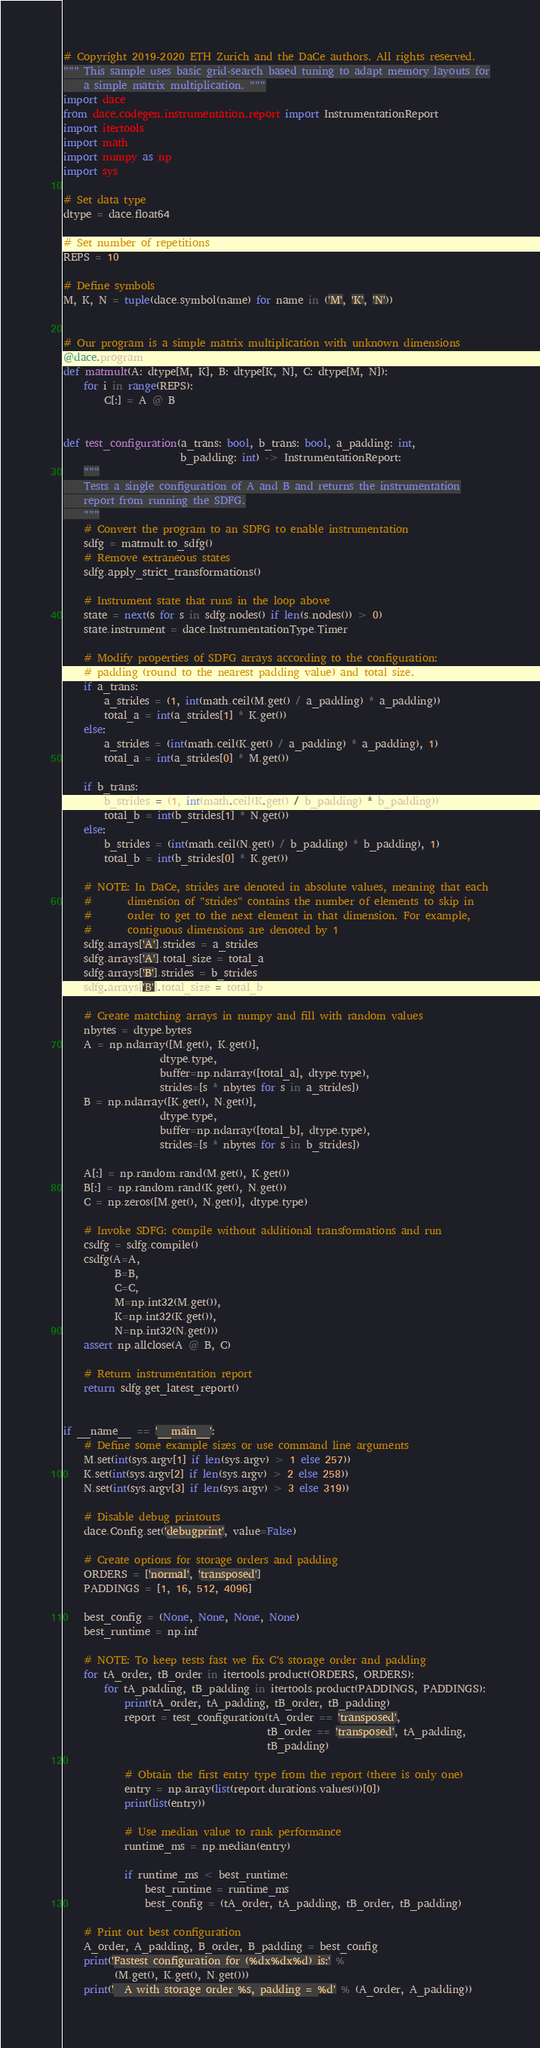Convert code to text. <code><loc_0><loc_0><loc_500><loc_500><_Python_># Copyright 2019-2020 ETH Zurich and the DaCe authors. All rights reserved.
""" This sample uses basic grid-search based tuning to adapt memory layouts for
    a simple matrix multiplication. """
import dace
from dace.codegen.instrumentation.report import InstrumentationReport
import itertools
import math
import numpy as np
import sys

# Set data type
dtype = dace.float64

# Set number of repetitions
REPS = 10

# Define symbols
M, K, N = tuple(dace.symbol(name) for name in ('M', 'K', 'N'))


# Our program is a simple matrix multiplication with unknown dimensions
@dace.program
def matmult(A: dtype[M, K], B: dtype[K, N], C: dtype[M, N]):
    for i in range(REPS):
        C[:] = A @ B


def test_configuration(a_trans: bool, b_trans: bool, a_padding: int,
                       b_padding: int) -> InstrumentationReport:
    """
    Tests a single configuration of A and B and returns the instrumentation
    report from running the SDFG.
    """
    # Convert the program to an SDFG to enable instrumentation
    sdfg = matmult.to_sdfg()
    # Remove extraneous states
    sdfg.apply_strict_transformations()

    # Instrument state that runs in the loop above
    state = next(s for s in sdfg.nodes() if len(s.nodes()) > 0)
    state.instrument = dace.InstrumentationType.Timer

    # Modify properties of SDFG arrays according to the configuration:
    # padding (round to the nearest padding value) and total size.
    if a_trans:
        a_strides = (1, int(math.ceil(M.get() / a_padding) * a_padding))
        total_a = int(a_strides[1] * K.get())
    else:
        a_strides = (int(math.ceil(K.get() / a_padding) * a_padding), 1)
        total_a = int(a_strides[0] * M.get())

    if b_trans:
        b_strides = (1, int(math.ceil(K.get() / b_padding) * b_padding))
        total_b = int(b_strides[1] * N.get())
    else:
        b_strides = (int(math.ceil(N.get() / b_padding) * b_padding), 1)
        total_b = int(b_strides[0] * K.get())

    # NOTE: In DaCe, strides are denoted in absolute values, meaning that each
    #       dimension of "strides" contains the number of elements to skip in
    #       order to get to the next element in that dimension. For example,
    #       contiguous dimensions are denoted by 1
    sdfg.arrays['A'].strides = a_strides
    sdfg.arrays['A'].total_size = total_a
    sdfg.arrays['B'].strides = b_strides
    sdfg.arrays['B'].total_size = total_b

    # Create matching arrays in numpy and fill with random values
    nbytes = dtype.bytes
    A = np.ndarray([M.get(), K.get()],
                   dtype.type,
                   buffer=np.ndarray([total_a], dtype.type),
                   strides=[s * nbytes for s in a_strides])
    B = np.ndarray([K.get(), N.get()],
                   dtype.type,
                   buffer=np.ndarray([total_b], dtype.type),
                   strides=[s * nbytes for s in b_strides])

    A[:] = np.random.rand(M.get(), K.get())
    B[:] = np.random.rand(K.get(), N.get())
    C = np.zeros([M.get(), N.get()], dtype.type)

    # Invoke SDFG: compile without additional transformations and run
    csdfg = sdfg.compile()
    csdfg(A=A,
          B=B,
          C=C,
          M=np.int32(M.get()),
          K=np.int32(K.get()),
          N=np.int32(N.get()))
    assert np.allclose(A @ B, C)

    # Return instrumentation report
    return sdfg.get_latest_report()


if __name__ == '__main__':
    # Define some example sizes or use command line arguments
    M.set(int(sys.argv[1] if len(sys.argv) > 1 else 257))
    K.set(int(sys.argv[2] if len(sys.argv) > 2 else 258))
    N.set(int(sys.argv[3] if len(sys.argv) > 3 else 319))

    # Disable debug printouts
    dace.Config.set('debugprint', value=False)

    # Create options for storage orders and padding
    ORDERS = ['normal', 'transposed']
    PADDINGS = [1, 16, 512, 4096]

    best_config = (None, None, None, None)
    best_runtime = np.inf

    # NOTE: To keep tests fast we fix C's storage order and padding
    for tA_order, tB_order in itertools.product(ORDERS, ORDERS):
        for tA_padding, tB_padding in itertools.product(PADDINGS, PADDINGS):
            print(tA_order, tA_padding, tB_order, tB_padding)
            report = test_configuration(tA_order == 'transposed',
                                        tB_order == 'transposed', tA_padding,
                                        tB_padding)

            # Obtain the first entry type from the report (there is only one)
            entry = np.array(list(report.durations.values())[0])
            print(list(entry))

            # Use median value to rank performance
            runtime_ms = np.median(entry)

            if runtime_ms < best_runtime:
                best_runtime = runtime_ms
                best_config = (tA_order, tA_padding, tB_order, tB_padding)

    # Print out best configuration
    A_order, A_padding, B_order, B_padding = best_config
    print('Fastest configuration for (%dx%dx%d) is:' %
          (M.get(), K.get(), N.get()))
    print('  A with storage order %s, padding = %d' % (A_order, A_padding))</code> 